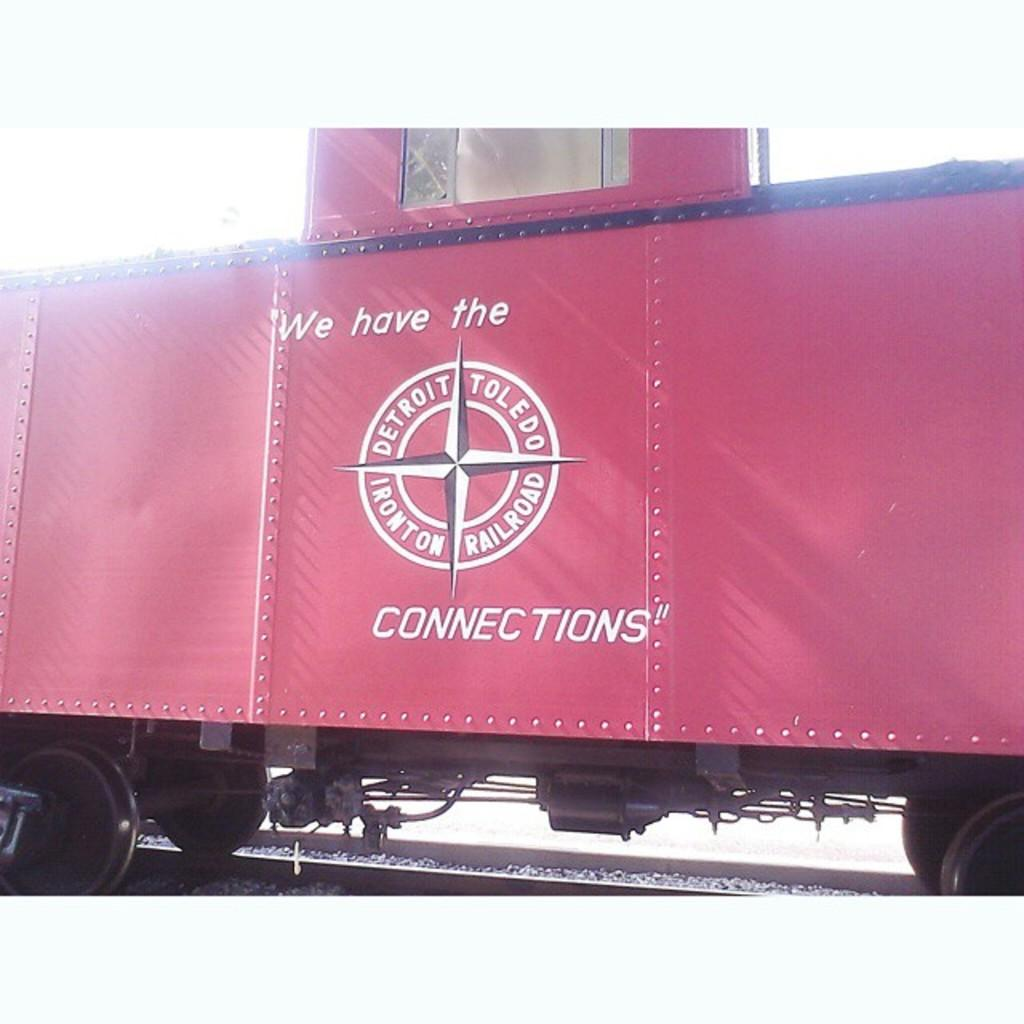What is the main subject of the image? The main subject of the image is a train. Where is the train located in the image? The train is in the middle of the image. What is the color of the train? The train is red in color. What is the train placed on in the image? The train is placed on a railway track. What type of leather material can be seen on the train in the image? There is no leather material visible on the train in the image. How many brothers are present in the image? There are no people, including brothers, present in the image; it only features a train on a railway track. 